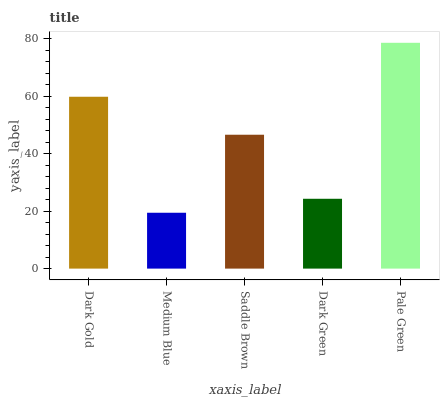Is Medium Blue the minimum?
Answer yes or no. Yes. Is Pale Green the maximum?
Answer yes or no. Yes. Is Saddle Brown the minimum?
Answer yes or no. No. Is Saddle Brown the maximum?
Answer yes or no. No. Is Saddle Brown greater than Medium Blue?
Answer yes or no. Yes. Is Medium Blue less than Saddle Brown?
Answer yes or no. Yes. Is Medium Blue greater than Saddle Brown?
Answer yes or no. No. Is Saddle Brown less than Medium Blue?
Answer yes or no. No. Is Saddle Brown the high median?
Answer yes or no. Yes. Is Saddle Brown the low median?
Answer yes or no. Yes. Is Dark Green the high median?
Answer yes or no. No. Is Dark Green the low median?
Answer yes or no. No. 